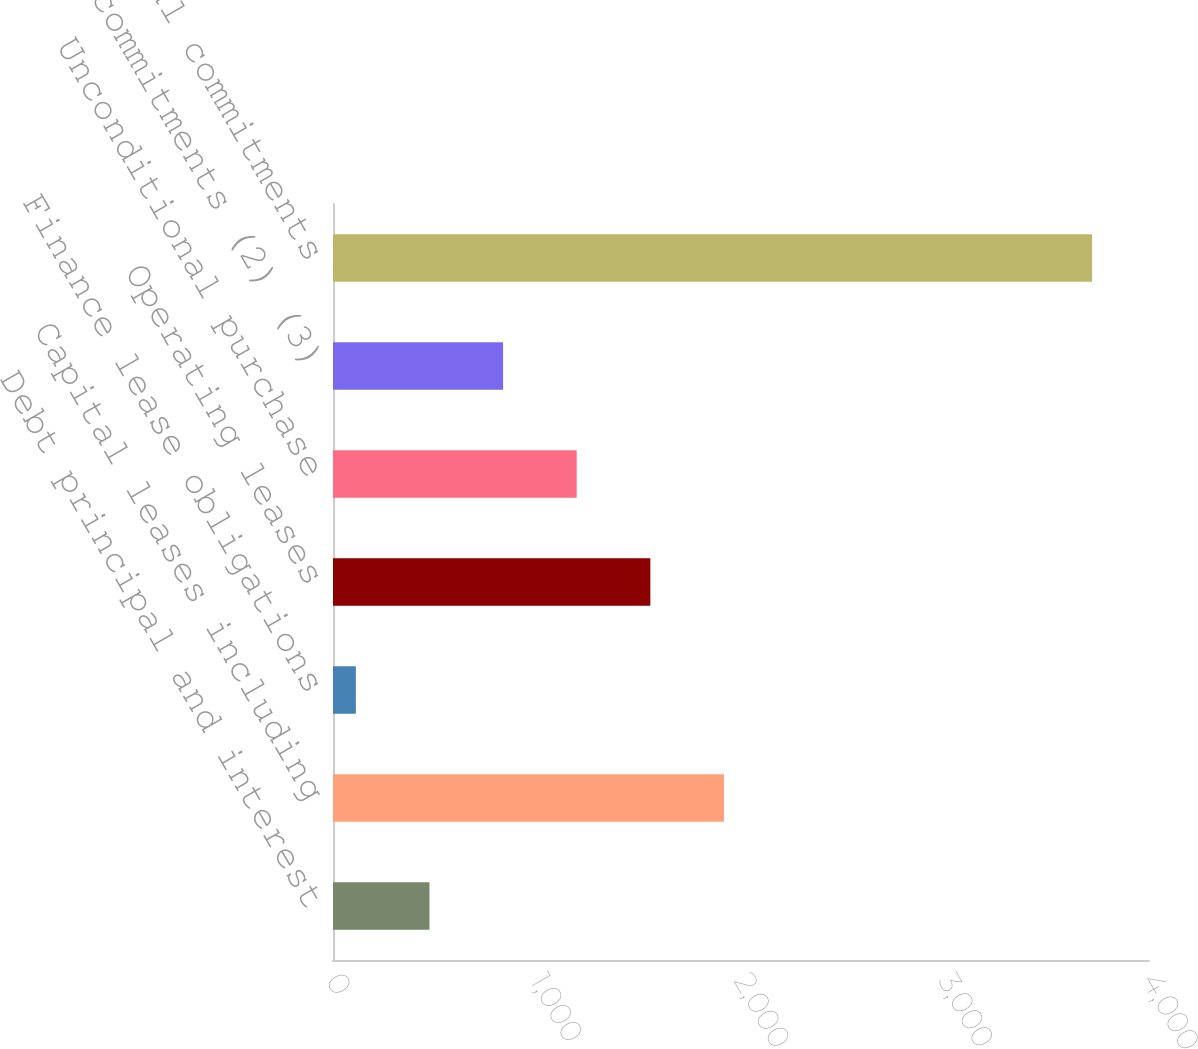Convert chart. <chart><loc_0><loc_0><loc_500><loc_500><bar_chart><fcel>Debt principal and interest<fcel>Capital leases including<fcel>Finance lease obligations<fcel>Operating leases<fcel>Unconditional purchase<fcel>Other commitments (2) (3)<fcel>Total commitments<nl><fcel>472.9<fcel>1916.5<fcel>112<fcel>1555.6<fcel>1194.7<fcel>833.8<fcel>3721<nl></chart> 